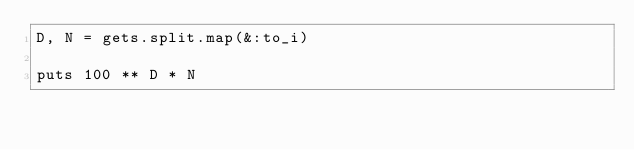Convert code to text. <code><loc_0><loc_0><loc_500><loc_500><_Ruby_>D, N = gets.split.map(&:to_i)

puts 100 ** D * N</code> 